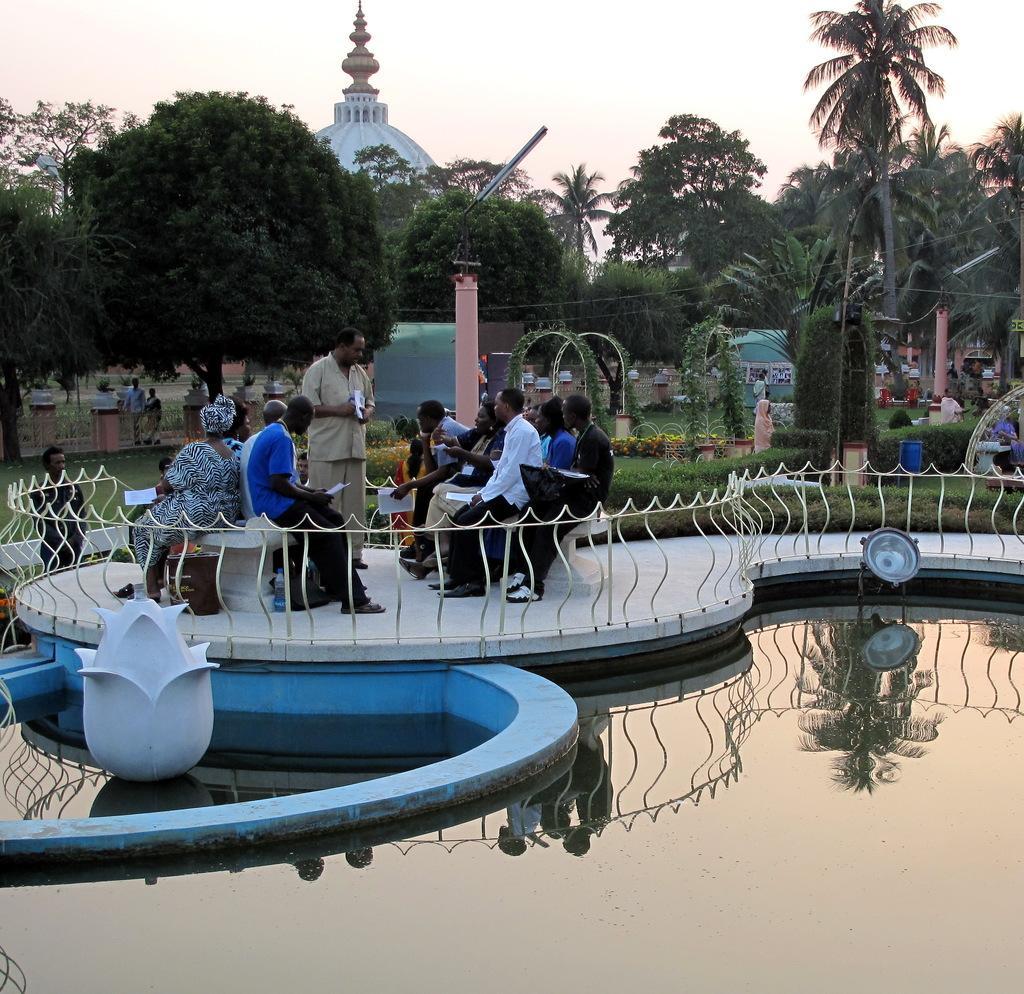How would you summarize this image in a sentence or two? In this picture I can observe some people in the middle of the picture. There are men and women in this picture. In the bottom of the picture I can observe pond. I can observe railing in the middle of the picture. In the background there are trees and sky. 